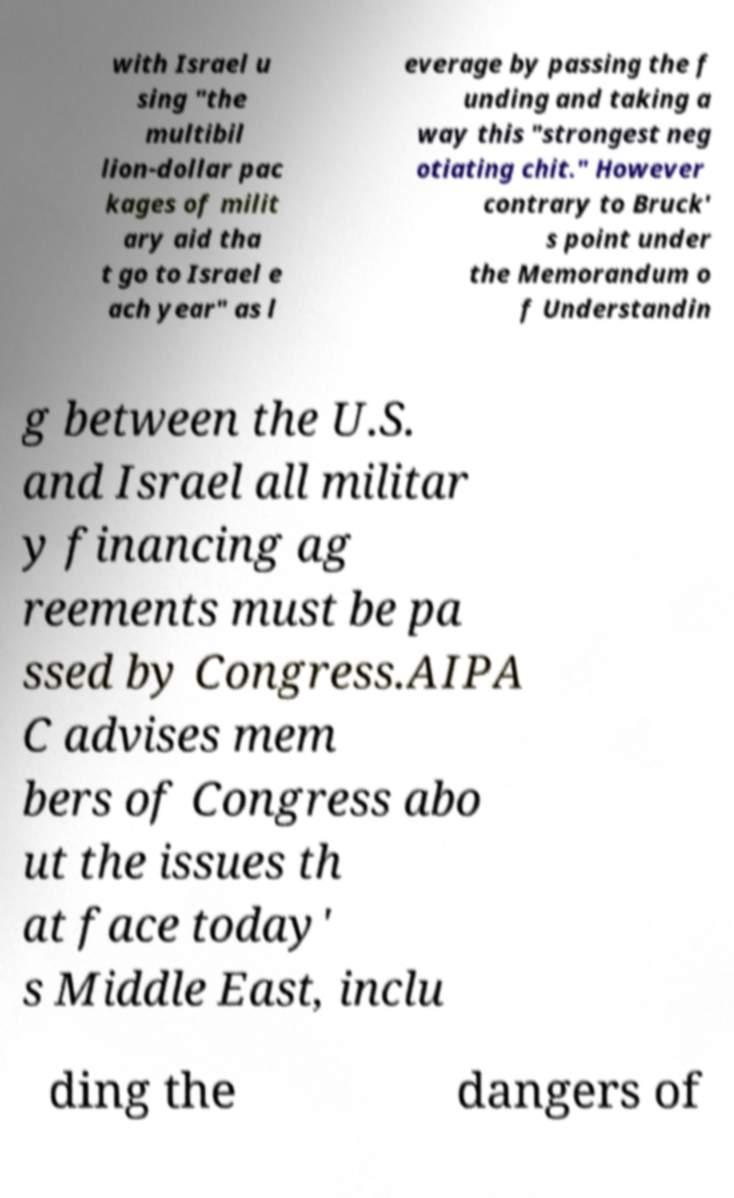What messages or text are displayed in this image? I need them in a readable, typed format. with Israel u sing "the multibil lion-dollar pac kages of milit ary aid tha t go to Israel e ach year" as l everage by passing the f unding and taking a way this "strongest neg otiating chit." However contrary to Bruck' s point under the Memorandum o f Understandin g between the U.S. and Israel all militar y financing ag reements must be pa ssed by Congress.AIPA C advises mem bers of Congress abo ut the issues th at face today' s Middle East, inclu ding the dangers of 